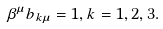<formula> <loc_0><loc_0><loc_500><loc_500>\beta ^ { \mu } b _ { k \mu } = 1 , k = 1 , 2 , 3 .</formula> 